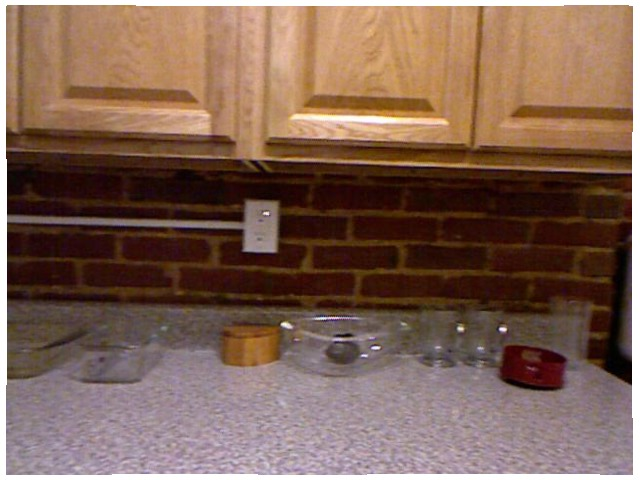<image>
Can you confirm if the floor is on the bowl? No. The floor is not positioned on the bowl. They may be near each other, but the floor is not supported by or resting on top of the bowl. Is the socket under the brick? No. The socket is not positioned under the brick. The vertical relationship between these objects is different. 